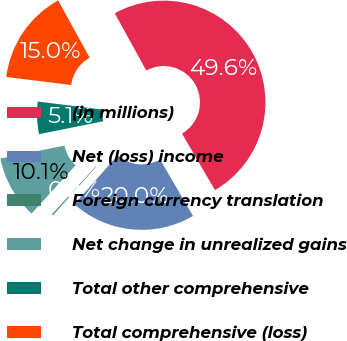<chart> <loc_0><loc_0><loc_500><loc_500><pie_chart><fcel>(in millions)<fcel>Net (loss) income<fcel>Foreign currency translation<fcel>Net change in unrealized gains<fcel>Total other comprehensive<fcel>Total comprehensive (loss)<nl><fcel>49.61%<fcel>19.96%<fcel>0.2%<fcel>10.08%<fcel>5.14%<fcel>15.02%<nl></chart> 